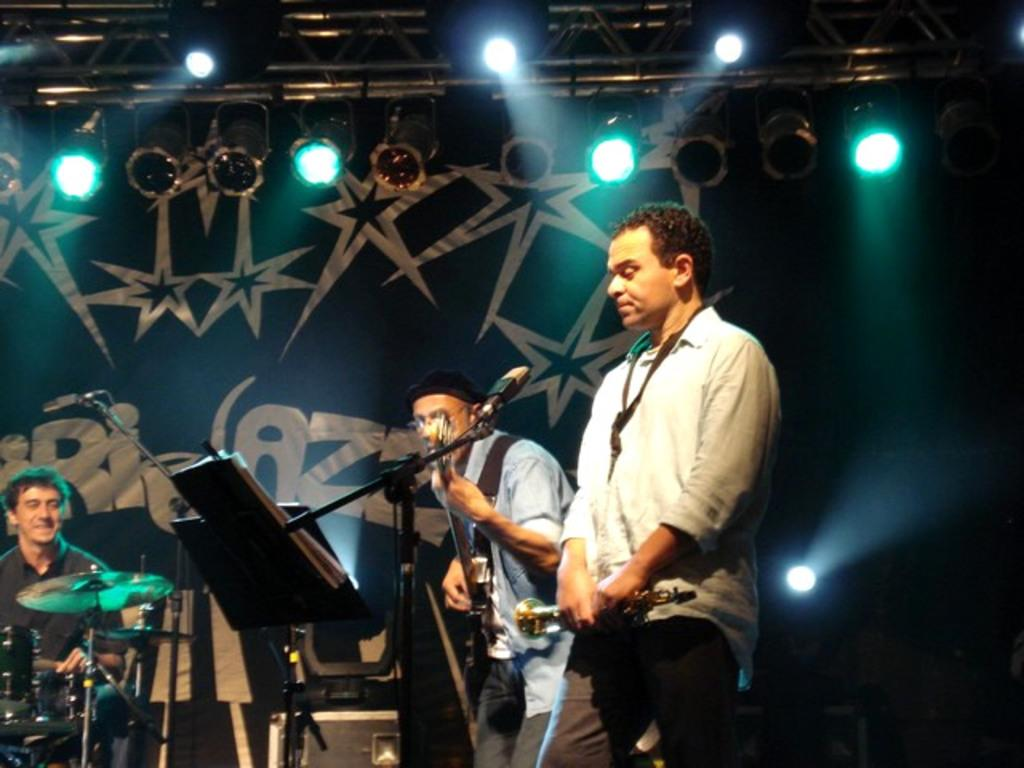How many people are in the image? There are three persons in the image. What are the people in the image doing? Each person is playing a different musical instrument. Can you describe the musical instruments being played? Unfortunately, the specific instruments cannot be identified from the provided facts. What type of card is being used to play the musical instrument in the image? There is no card present in the image, and the musical instruments are not being played with any cards. 